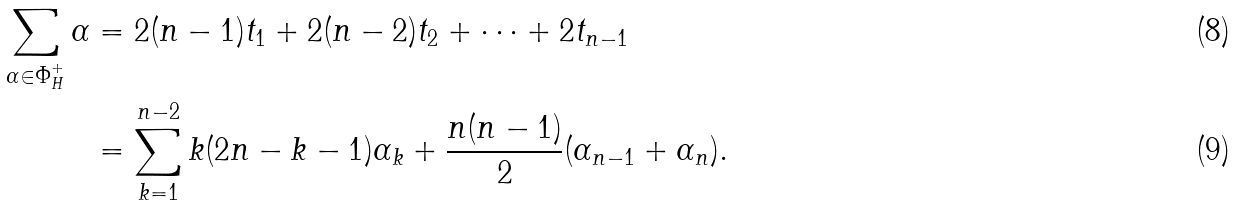<formula> <loc_0><loc_0><loc_500><loc_500>\sum _ { \alpha \in \Phi _ { H } ^ { + } } \alpha & = 2 ( n - 1 ) t _ { 1 } + 2 ( n - 2 ) t _ { 2 } + \dots + 2 t _ { n - 1 } \\ & = \sum _ { k = 1 } ^ { n - 2 } k ( 2 n - k - 1 ) \alpha _ { k } + \frac { n ( n - 1 ) } { 2 } ( \alpha _ { n - 1 } + \alpha _ { n } ) .</formula> 